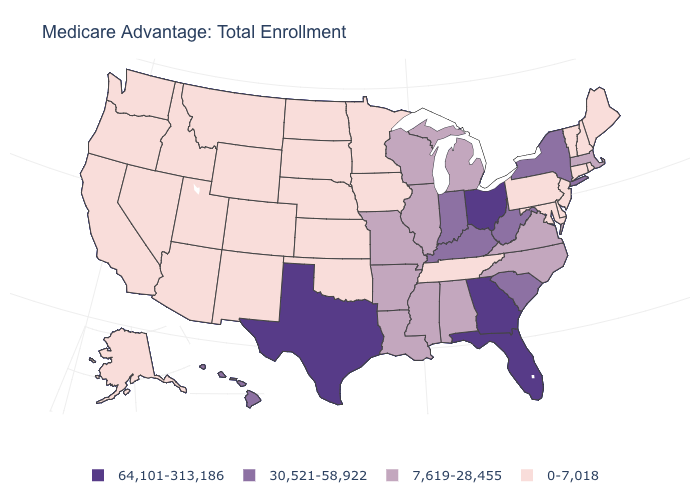Does Utah have the same value as South Carolina?
Give a very brief answer. No. Is the legend a continuous bar?
Quick response, please. No. How many symbols are there in the legend?
Keep it brief. 4. Among the states that border Iowa , does Missouri have the highest value?
Quick response, please. Yes. What is the value of Massachusetts?
Short answer required. 7,619-28,455. Which states have the lowest value in the West?
Give a very brief answer. Alaska, Arizona, California, Colorado, Idaho, Montana, New Mexico, Nevada, Oregon, Utah, Washington, Wyoming. Does the first symbol in the legend represent the smallest category?
Keep it brief. No. What is the lowest value in the USA?
Give a very brief answer. 0-7,018. Which states have the lowest value in the USA?
Keep it brief. Alaska, Arizona, California, Colorado, Connecticut, Delaware, Iowa, Idaho, Kansas, Maryland, Maine, Minnesota, Montana, North Dakota, Nebraska, New Hampshire, New Jersey, New Mexico, Nevada, Oklahoma, Oregon, Pennsylvania, Rhode Island, South Dakota, Tennessee, Utah, Vermont, Washington, Wyoming. What is the lowest value in the South?
Quick response, please. 0-7,018. What is the value of Illinois?
Give a very brief answer. 7,619-28,455. What is the highest value in states that border Virginia?
Write a very short answer. 30,521-58,922. Name the states that have a value in the range 7,619-28,455?
Write a very short answer. Alabama, Arkansas, Illinois, Louisiana, Massachusetts, Michigan, Missouri, Mississippi, North Carolina, Virginia, Wisconsin. What is the highest value in the USA?
Write a very short answer. 64,101-313,186. What is the value of Nebraska?
Write a very short answer. 0-7,018. 